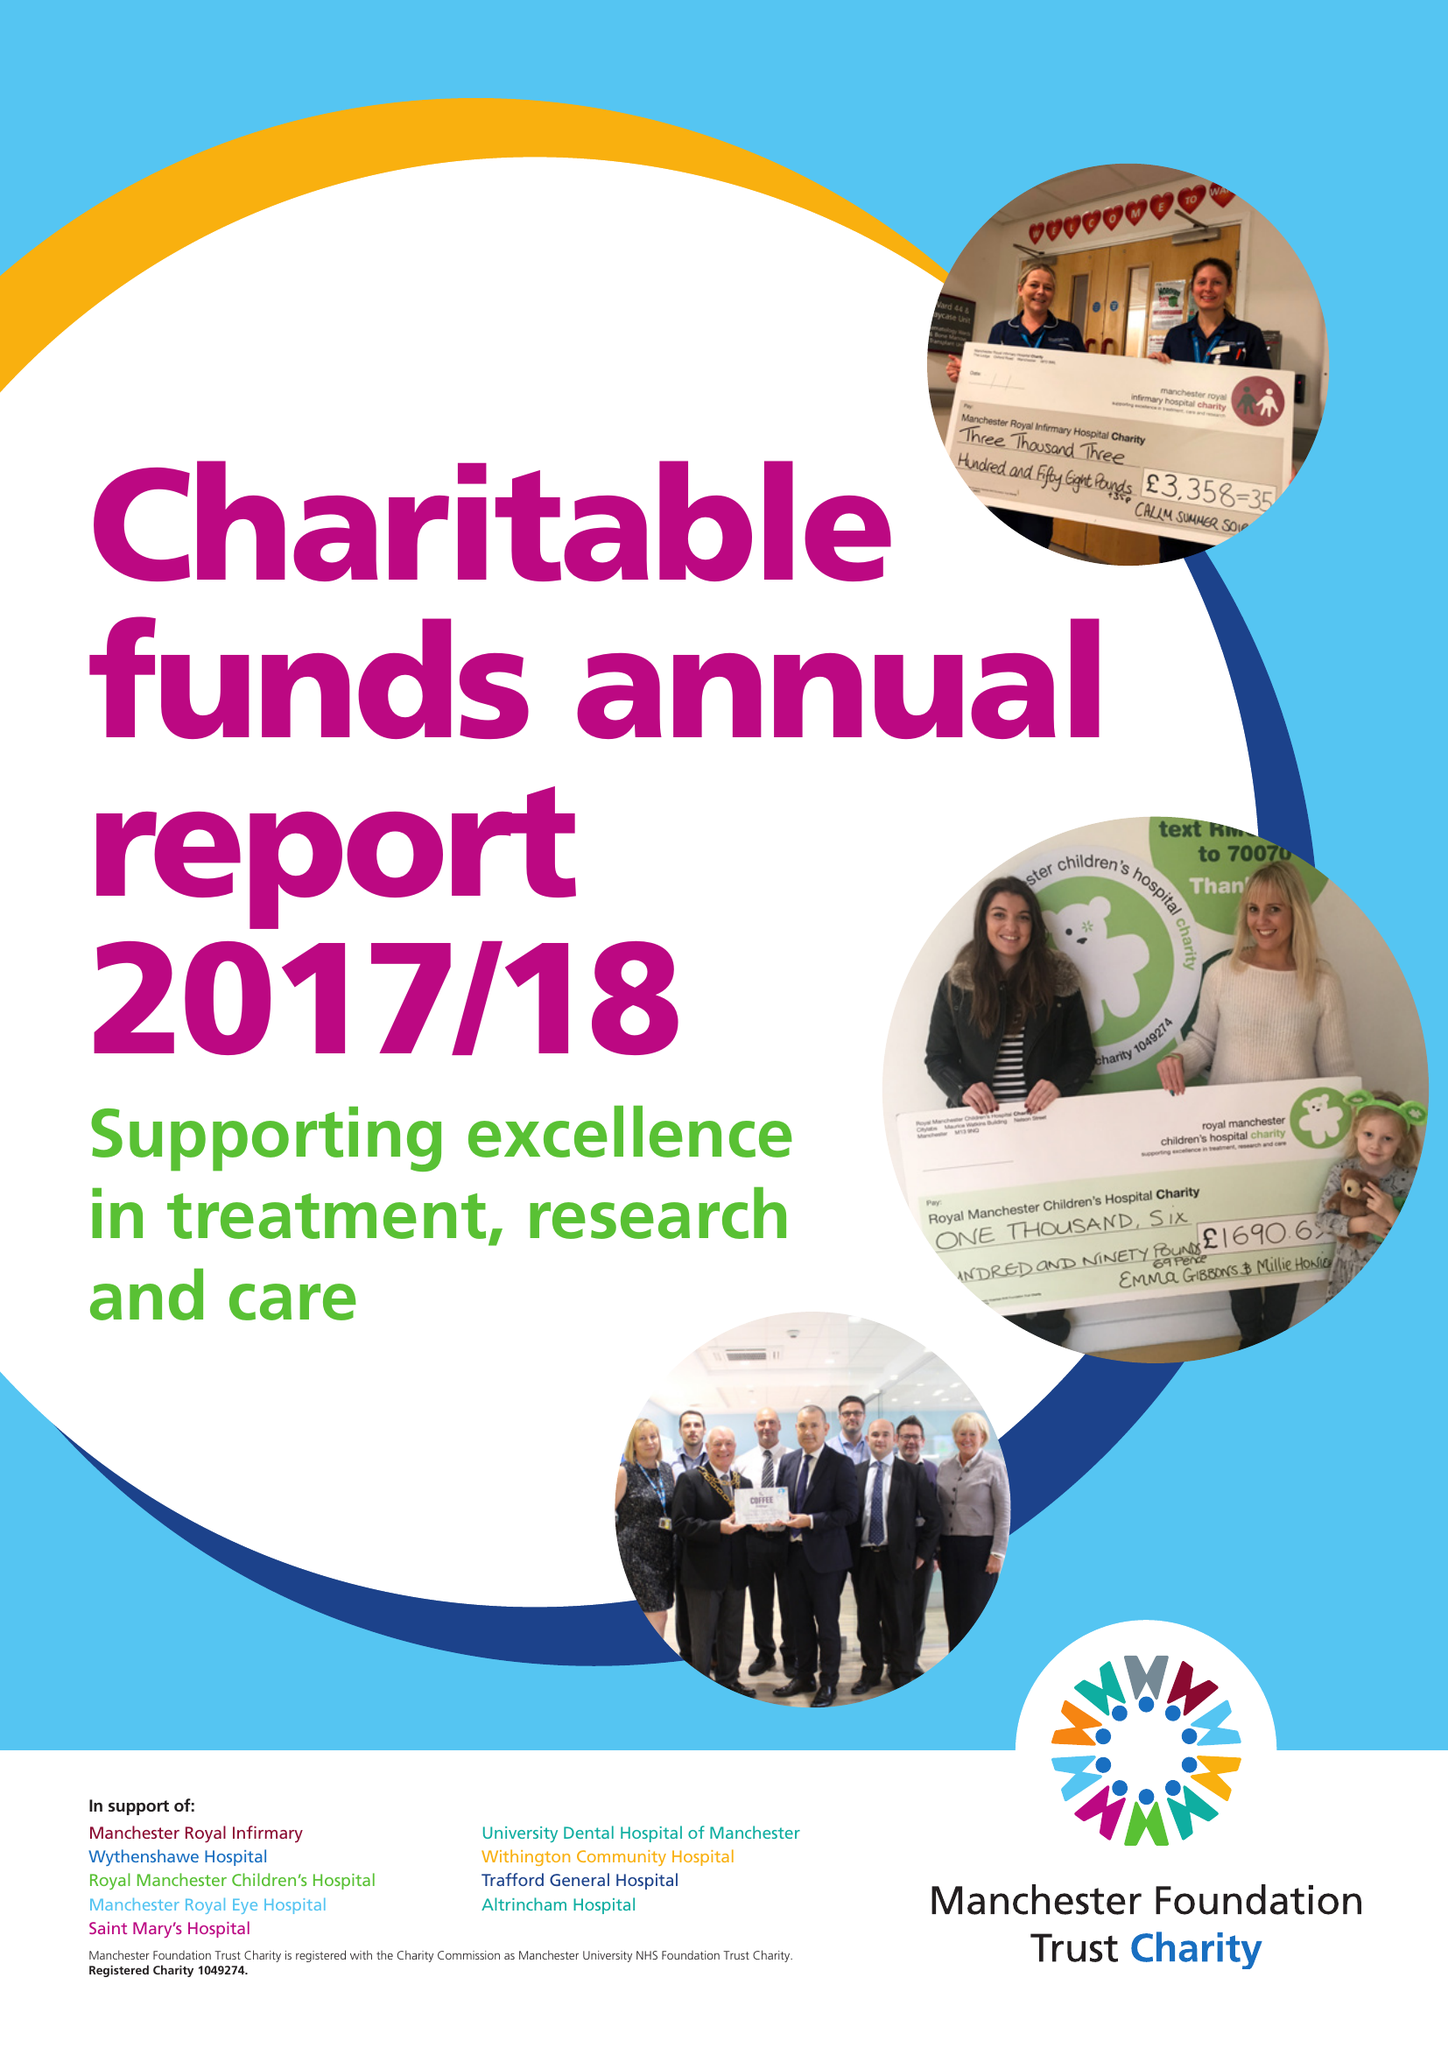What is the value for the address__street_line?
Answer the question using a single word or phrase. NELSON STREET 